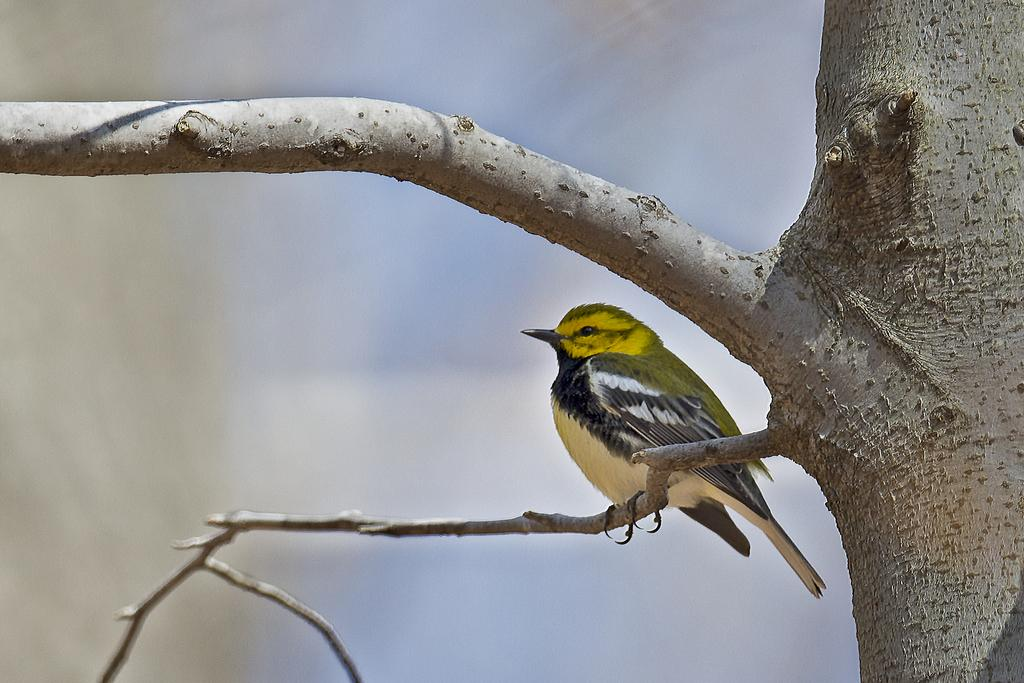What type of animal is in the image? There is a bird in the image. Where is the bird located? The bird is on a tree. Can you describe the background of the image? The background of the image is blurred. How many toothbrushes are hanging from the branches of the tree in the image? There are no toothbrushes present in the image; it features a bird on a tree with a blurred background. 